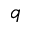<formula> <loc_0><loc_0><loc_500><loc_500>_ { q }</formula> 